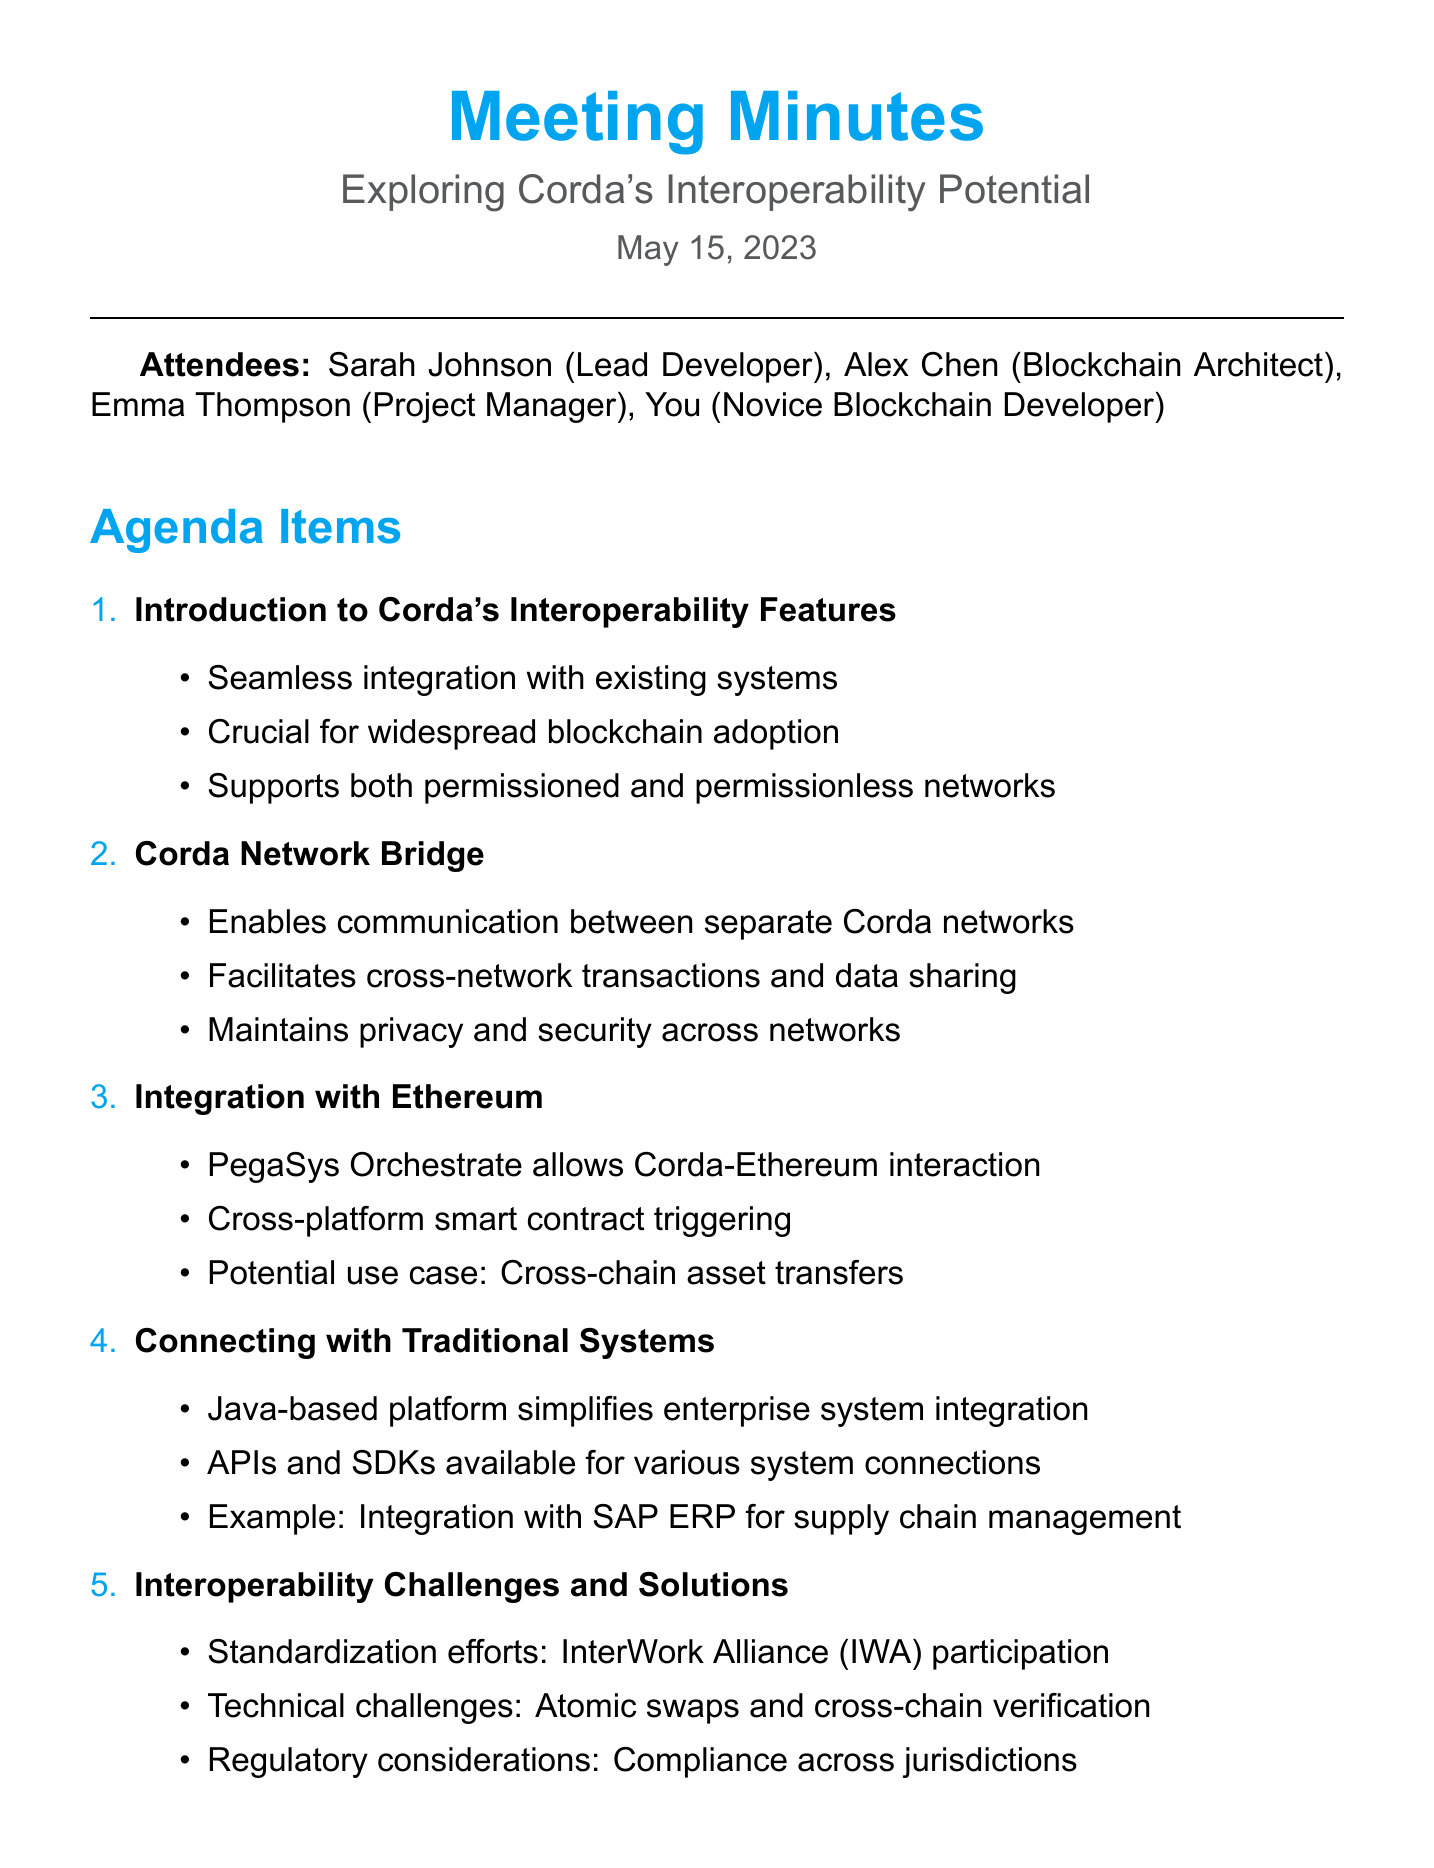What is the meeting title? The meeting title is stated at the beginning of the document.
Answer: Exploring Corda's Interoperability Potential Who is the lead developer? The lead developer is listed among the attendees of the meeting.
Answer: Sarah Johnson What date was the meeting held? The date of the meeting is provided in the document.
Answer: May 15, 2023 What is one key point about Corda's interoperability features? The key points are outlined under agenda items and highlight important aspects.
Answer: Seamless integration with existing systems What does the Corda Network Bridge enable? This is mentioned as a key point in the agenda item discussing the Network Bridge.
Answer: Communication between separate Corda networks Which platform allows interaction between Corda and Ethereum? Information regarding the integration with Ethereum includes specific tools used for interoperability.
Answer: PegaSys Orchestrate What is an example of connecting Corda with traditional systems? The document provides specific examples of integration within traditional systems.
Answer: Integration with SAP ERP for supply chain management What is one challenge mentioned regarding interoperability? Challenges are outlined under the agenda item discussing interoperability.
Answer: Atomic swaps What is one next step identified in the meeting? The action items listed detail the next steps to be taken following the meeting.
Answer: Research PegaSys Orchestrate documentation 